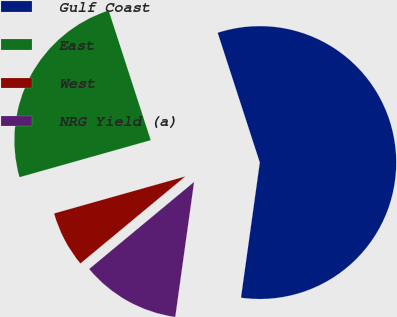Convert chart. <chart><loc_0><loc_0><loc_500><loc_500><pie_chart><fcel>Gulf Coast<fcel>East<fcel>West<fcel>NRG Yield (a)<nl><fcel>57.2%<fcel>24.38%<fcel>6.65%<fcel>11.77%<nl></chart> 